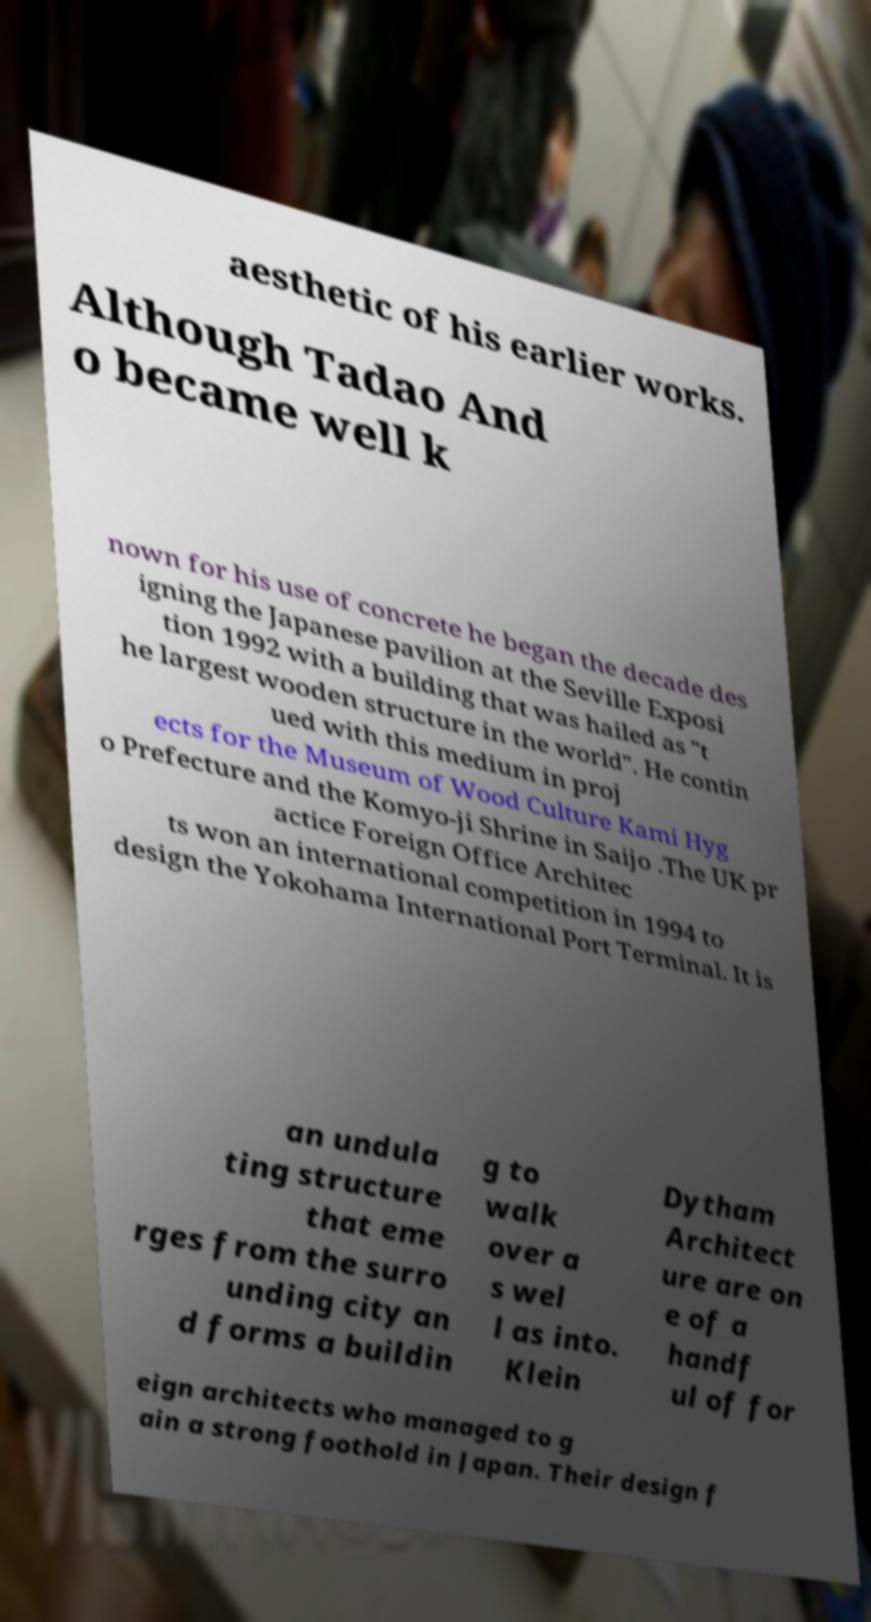Can you accurately transcribe the text from the provided image for me? aesthetic of his earlier works. Although Tadao And o became well k nown for his use of concrete he began the decade des igning the Japanese pavilion at the Seville Exposi tion 1992 with a building that was hailed as "t he largest wooden structure in the world". He contin ued with this medium in proj ects for the Museum of Wood Culture Kami Hyg o Prefecture and the Komyo-ji Shrine in Saijo .The UK pr actice Foreign Office Architec ts won an international competition in 1994 to design the Yokohama International Port Terminal. It is an undula ting structure that eme rges from the surro unding city an d forms a buildin g to walk over a s wel l as into. Klein Dytham Architect ure are on e of a handf ul of for eign architects who managed to g ain a strong foothold in Japan. Their design f 